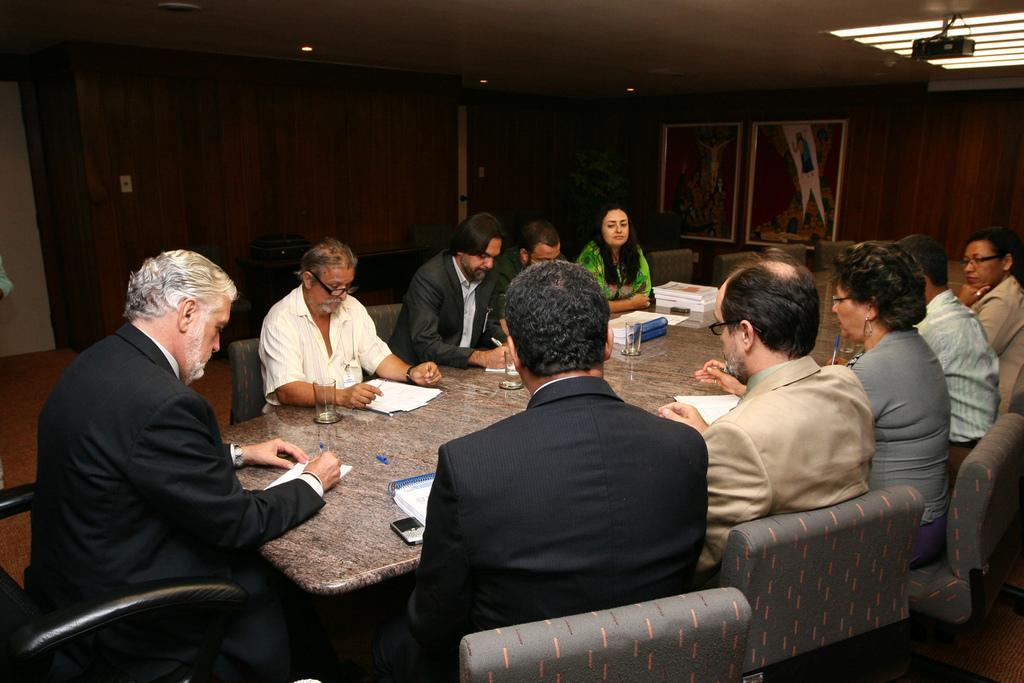Can you describe this image briefly? The image is taken in the room. In the center of the image there is a table and there are people sitting around the table. On the table there are glasses, papers, books, and mobiles. In the background there are photo frames and wall. 